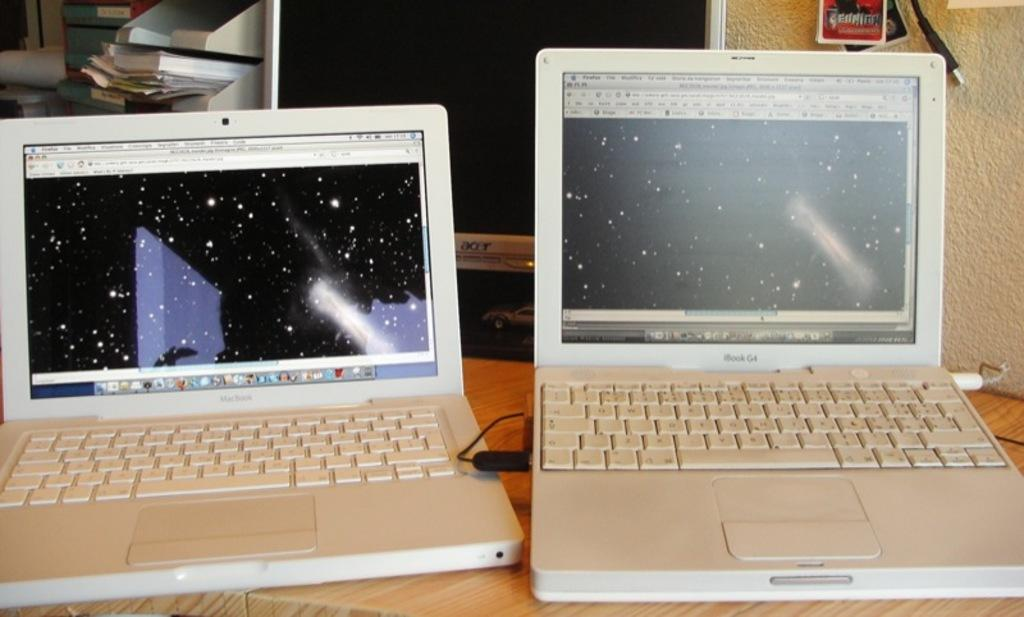How many laptops are in the image? There are two laptops in the image. What color are the laptops? The laptops are white in color. Where are the laptops located? The laptops are on a table. What can be seen in the background of the image? Papers, a screen, and other objects are visible in the background. What color is the wall in the image? The wall is cream-colored. Can you see any grass growing on the laptops in the image? No, there is no grass visible on the laptops or anywhere in the image. 